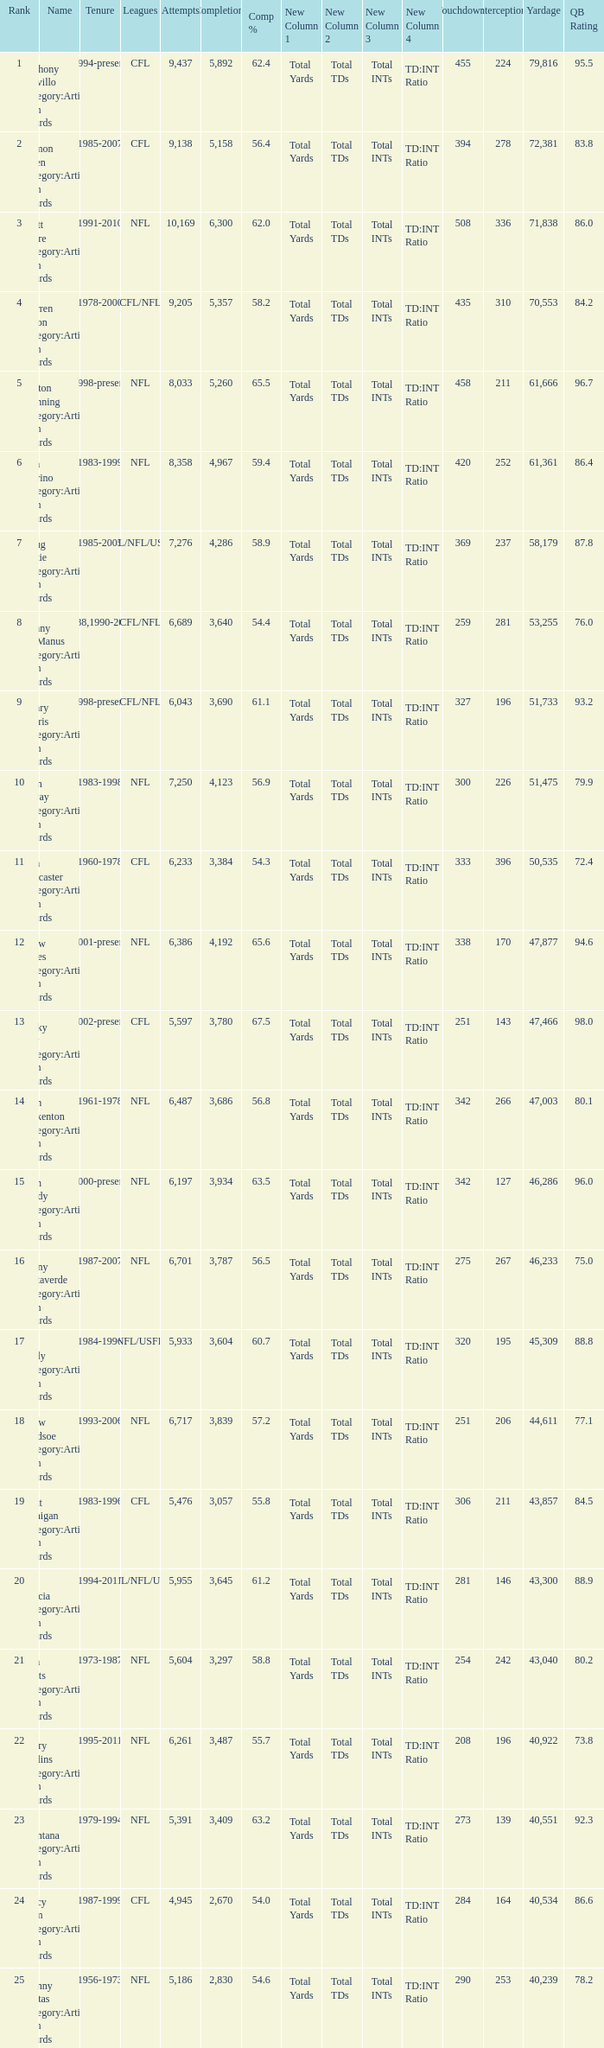What is the rank when there are more than 4,123 completion and the comp percentage is more than 65.6? None. Could you parse the entire table? {'header': ['Rank', 'Name', 'Tenure', 'Leagues', 'Attempts', 'Completions', 'Comp %', 'New Column 1', 'New Column 2', 'New Column 3', 'New Column 4', 'Touchdowns', 'Interceptions', 'Yardage', 'QB Rating'], 'rows': [['1', 'Anthony Calvillo Category:Articles with hCards', '1994-present', 'CFL', '9,437', '5,892', '62.4', 'Total Yards', 'Total TDs', 'Total INTs', 'TD:INT Ratio', '455', '224', '79,816', '95.5'], ['2', 'Damon Allen Category:Articles with hCards', '1985-2007', 'CFL', '9,138', '5,158', '56.4', 'Total Yards', 'Total TDs', 'Total INTs', 'TD:INT Ratio', '394', '278', '72,381', '83.8'], ['3', 'Brett Favre Category:Articles with hCards', '1991-2010', 'NFL', '10,169', '6,300', '62.0', 'Total Yards', 'Total TDs', 'Total INTs', 'TD:INT Ratio', '508', '336', '71,838', '86.0'], ['4', 'Warren Moon Category:Articles with hCards', '1978-2000', 'CFL/NFL', '9,205', '5,357', '58.2', 'Total Yards', 'Total TDs', 'Total INTs', 'TD:INT Ratio', '435', '310', '70,553', '84.2'], ['5', 'Peyton Manning Category:Articles with hCards', '1998-present', 'NFL', '8,033', '5,260', '65.5', 'Total Yards', 'Total TDs', 'Total INTs', 'TD:INT Ratio', '458', '211', '61,666', '96.7'], ['6', 'Dan Marino Category:Articles with hCards', '1983-1999', 'NFL', '8,358', '4,967', '59.4', 'Total Yards', 'Total TDs', 'Total INTs', 'TD:INT Ratio', '420', '252', '61,361', '86.4'], ['7', 'Doug Flutie Category:Articles with hCards', '1985-2005', 'CFL/NFL/USFL', '7,276', '4,286', '58.9', 'Total Yards', 'Total TDs', 'Total INTs', 'TD:INT Ratio', '369', '237', '58,179', '87.8'], ['8', 'Danny McManus Category:Articles with hCards', '1988,1990-2006', 'CFL/NFL', '6,689', '3,640', '54.4', 'Total Yards', 'Total TDs', 'Total INTs', 'TD:INT Ratio', '259', '281', '53,255', '76.0'], ['9', 'Henry Burris Category:Articles with hCards', '1998-present', 'CFL/NFL', '6,043', '3,690', '61.1', 'Total Yards', 'Total TDs', 'Total INTs', 'TD:INT Ratio', '327', '196', '51,733', '93.2'], ['10', 'John Elway Category:Articles with hCards', '1983-1998', 'NFL', '7,250', '4,123', '56.9', 'Total Yards', 'Total TDs', 'Total INTs', 'TD:INT Ratio', '300', '226', '51,475', '79.9'], ['11', 'Ron Lancaster Category:Articles with hCards', '1960-1978', 'CFL', '6,233', '3,384', '54.3', 'Total Yards', 'Total TDs', 'Total INTs', 'TD:INT Ratio', '333', '396', '50,535', '72.4'], ['12', 'Drew Brees Category:Articles with hCards', '2001-present', 'NFL', '6,386', '4,192', '65.6', 'Total Yards', 'Total TDs', 'Total INTs', 'TD:INT Ratio', '338', '170', '47,877', '94.6'], ['13', 'Ricky Ray Category:Articles with hCards', '2002-present', 'CFL', '5,597', '3,780', '67.5', 'Total Yards', 'Total TDs', 'Total INTs', 'TD:INT Ratio', '251', '143', '47,466', '98.0'], ['14', 'Fran Tarkenton Category:Articles with hCards', '1961-1978', 'NFL', '6,487', '3,686', '56.8', 'Total Yards', 'Total TDs', 'Total INTs', 'TD:INT Ratio', '342', '266', '47,003', '80.1'], ['15', 'Tom Brady Category:Articles with hCards', '2000-present', 'NFL', '6,197', '3,934', '63.5', 'Total Yards', 'Total TDs', 'Total INTs', 'TD:INT Ratio', '342', '127', '46,286', '96.0'], ['16', 'Vinny Testaverde Category:Articles with hCards', '1987-2007', 'NFL', '6,701', '3,787', '56.5', 'Total Yards', 'Total TDs', 'Total INTs', 'TD:INT Ratio', '275', '267', '46,233', '75.0'], ['17', 'Jim Kelly Category:Articles with hCards', '1984-1996', 'NFL/USFL', '5,933', '3,604', '60.7', 'Total Yards', 'Total TDs', 'Total INTs', 'TD:INT Ratio', '320', '195', '45,309', '88.8'], ['18', 'Drew Bledsoe Category:Articles with hCards', '1993-2006', 'NFL', '6,717', '3,839', '57.2', 'Total Yards', 'Total TDs', 'Total INTs', 'TD:INT Ratio', '251', '206', '44,611', '77.1'], ['19', 'Matt Dunigan Category:Articles with hCards', '1983-1996', 'CFL', '5,476', '3,057', '55.8', 'Total Yards', 'Total TDs', 'Total INTs', 'TD:INT Ratio', '306', '211', '43,857', '84.5'], ['20', 'Jeff Garcia Category:Articles with hCards', '1994-2011', 'CFL/NFL/UFL', '5,955', '3,645', '61.2', 'Total Yards', 'Total TDs', 'Total INTs', 'TD:INT Ratio', '281', '146', '43,300', '88.9'], ['21', 'Dan Fouts Category:Articles with hCards', '1973-1987', 'NFL', '5,604', '3,297', '58.8', 'Total Yards', 'Total TDs', 'Total INTs', 'TD:INT Ratio', '254', '242', '43,040', '80.2'], ['22', 'Kerry Collins Category:Articles with hCards', '1995-2011', 'NFL', '6,261', '3,487', '55.7', 'Total Yards', 'Total TDs', 'Total INTs', 'TD:INT Ratio', '208', '196', '40,922', '73.8'], ['23', 'Joe Montana Category:Articles with hCards', '1979-1994', 'NFL', '5,391', '3,409', '63.2', 'Total Yards', 'Total TDs', 'Total INTs', 'TD:INT Ratio', '273', '139', '40,551', '92.3'], ['24', 'Tracy Ham Category:Articles with hCards', '1987-1999', 'CFL', '4,945', '2,670', '54.0', 'Total Yards', 'Total TDs', 'Total INTs', 'TD:INT Ratio', '284', '164', '40,534', '86.6'], ['25', 'Johnny Unitas Category:Articles with hCards', '1956-1973', 'NFL', '5,186', '2,830', '54.6', 'Total Yards', 'Total TDs', 'Total INTs', 'TD:INT Ratio', '290', '253', '40,239', '78.2']]} 